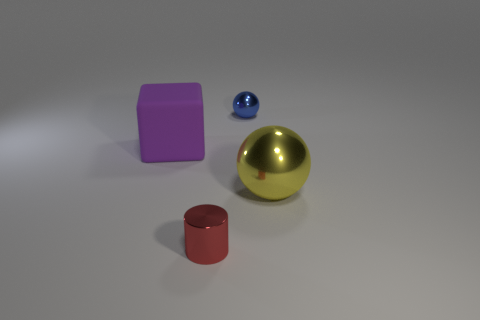Add 2 large red metallic cylinders. How many objects exist? 6 Subtract all blocks. How many objects are left? 3 Add 2 large metallic things. How many large metallic things are left? 3 Add 3 tiny metal things. How many tiny metal things exist? 5 Subtract 0 green cylinders. How many objects are left? 4 Subtract all red shiny things. Subtract all cubes. How many objects are left? 2 